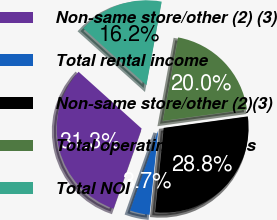Convert chart to OTSL. <chart><loc_0><loc_0><loc_500><loc_500><pie_chart><fcel>Non-same store/other (2) (3)<fcel>Total rental income<fcel>Non-same store/other (2)(3)<fcel>Total operating expenses<fcel>Total NOI<nl><fcel>31.3%<fcel>3.75%<fcel>28.79%<fcel>19.96%<fcel>16.21%<nl></chart> 